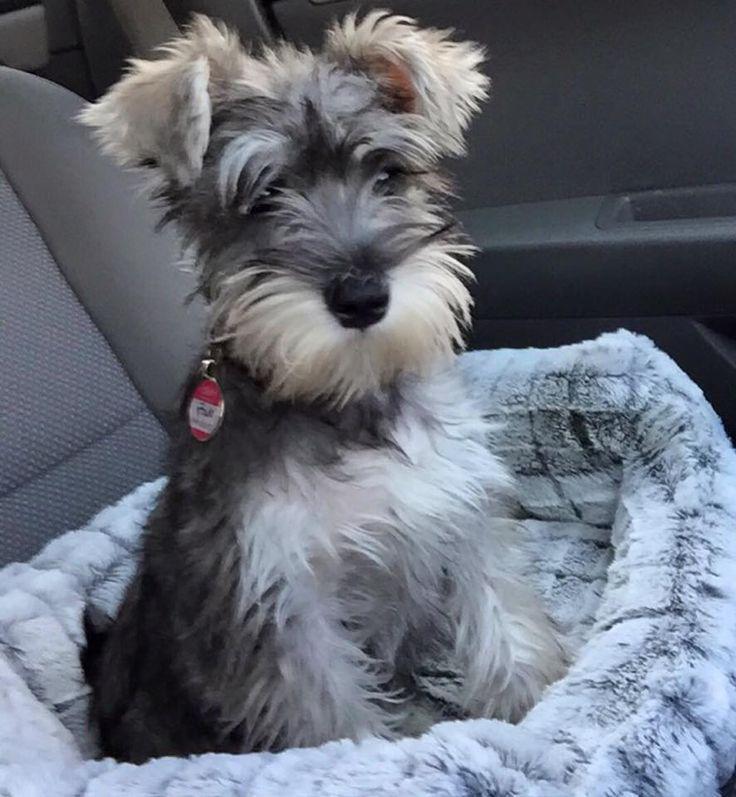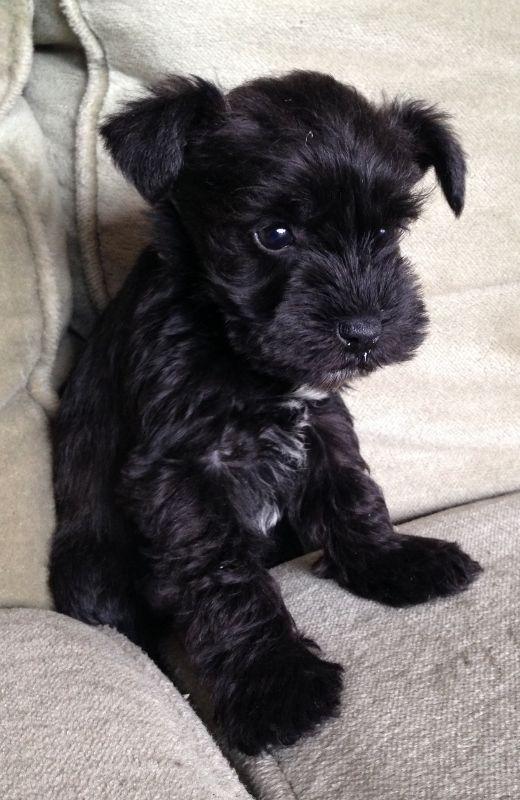The first image is the image on the left, the second image is the image on the right. For the images shown, is this caption "Left image features a schnauzer dog sitting inside a car on a seat." true? Answer yes or no. Yes. The first image is the image on the left, the second image is the image on the right. Given the left and right images, does the statement "One of the dogs is on a sidewalk near the grass." hold true? Answer yes or no. No. 